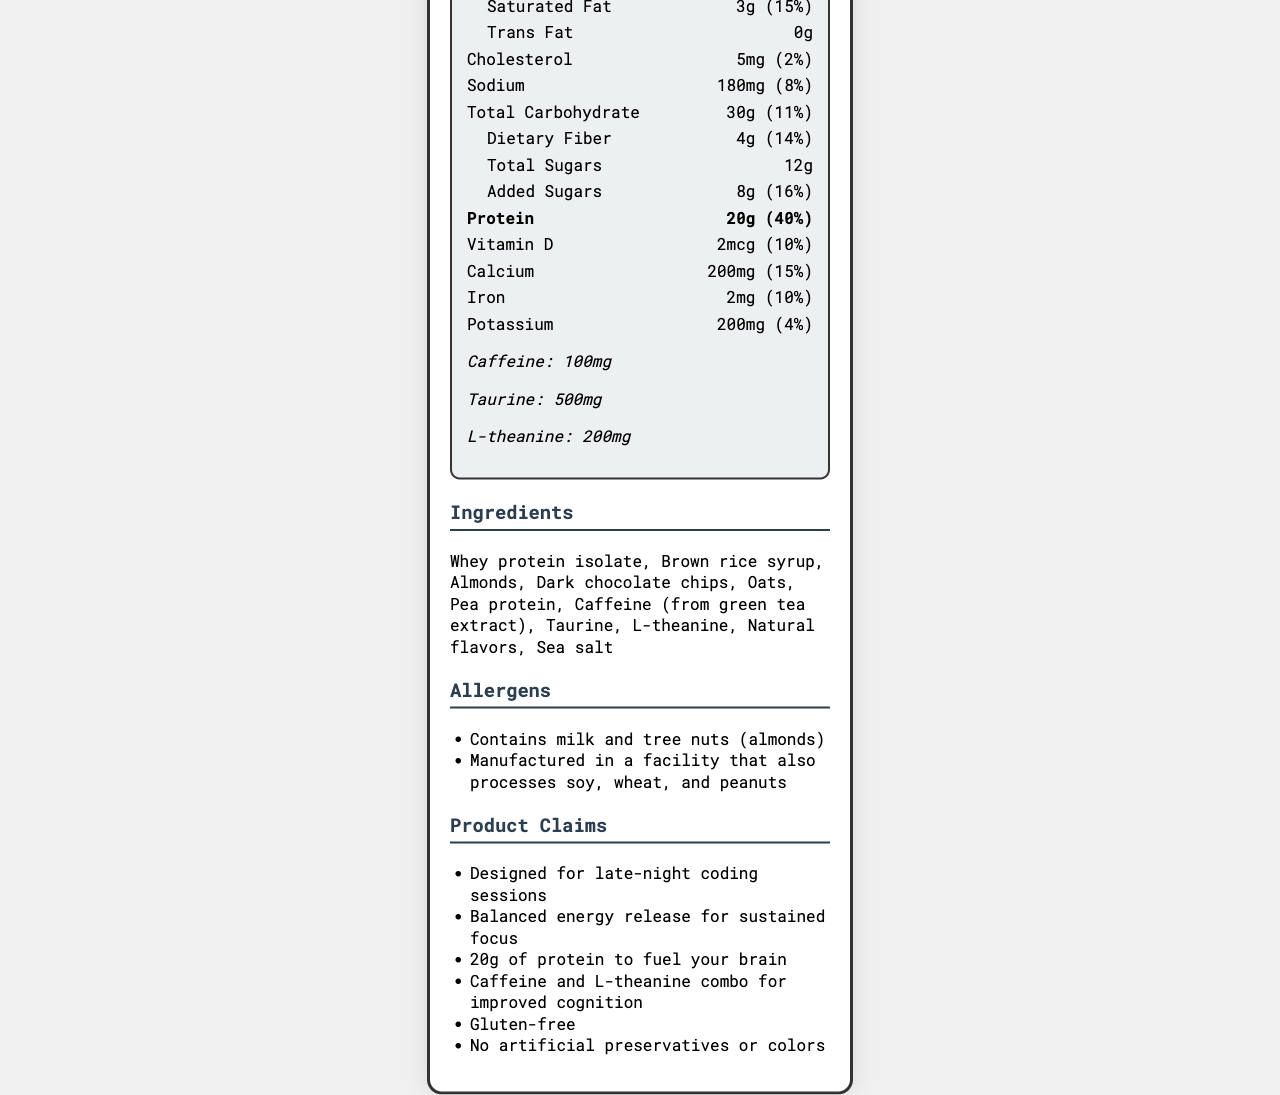what is the total fat content per serving? The nutrition facts section specifies that the total fat content per serving is 9g.
Answer: 9g how much caffeine is in one CodeFuel Energy Bar? The document lists caffeine as an ingredient with a specified amount of 100mg.
Answer: 100mg does this protein bar contain any trans fat? The nutrition facts section states that the trans fat content is 0g.
Answer: No how many servings are in one container? The label mentions that there are 6 servings per container.
Answer: 6 how much protein does one serving of the CodeFuel Energy Bar provide? The nutrition facts section specifies that the protein content per serving is 20g.
Answer: 20g what is the serving size of the CodeFuel Energy Bar? The label indicates that the serving size is 1 bar, which weighs 60g.
Answer: 1 bar (60g) what percentage of the daily value of calcium does one serving provide? A. 10% B. 12% C. 15% D. 20% The label shows that one serving provides 15% of the daily value for calcium.
Answer: C how much added sugar does the protein bar contain per serving? The nutrition facts section specifies that there are 8g of added sugars per serving.
Answer: 8g does the CodeFuel Energy Bar contain any artificial preservatives or colors? The marketing claims clearly state that there are no artificial preservatives or colors.
Answer: No which allergens are present in this protein bar? The allergens section indicates that the bar contains milk and tree nuts (almonds).
Answer: Milk and tree nuts (almonds) describe the main purpose of the CodeFuel Energy Bar. The marketing claims describe the bar as being designed for late-night coding sessions with balanced energy release, 20g of protein to fuel the brain, and the inclusion of caffeine and L-theanine for improved cognition. It is also gluten-free and contains no artificial preservatives or colors.
Answer: Designed for late-night coding sessions, provides balanced energy release, 20g of protein, includes caffeine and L-theanine for improved cognition, gluten-free, and no artificial preservatives or colors. how much vitamin D does one serving of the CodeFuel Energy Bar provide? The nutrition facts section specifies that one serving provides 2mcg of vitamin D.
Answer: 2mcg are there any ingredients sourced from animals in this bar? A. Yes B. No C. Cannot be determined The document does not provide information on whether the ingredients are sourced from animals or not.
Answer: C is this protein bar suitable for someone with a soy allergy? The allergens section warns that the bar is manufactured in a facility that processes soy.
Answer: No 